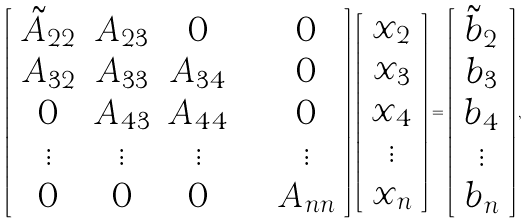<formula> <loc_0><loc_0><loc_500><loc_500>\left [ \begin{array} { c c c c c c } \tilde { A } _ { 2 2 } & A _ { 2 3 } & 0 & \cdots & 0 \\ A _ { 3 2 } & A _ { 3 3 } & A _ { 3 4 } & \cdots & 0 \\ 0 & A _ { 4 3 } & A _ { 4 4 } & \cdots & 0 \\ \vdots & \vdots & \vdots & & \vdots \\ 0 & 0 & 0 & \cdots & A _ { n n } \end{array} \right ] \, \left [ \begin{array} { c } x _ { 2 } \\ x _ { 3 } \\ x _ { 4 } \\ \vdots \\ x _ { n } \end{array} \right ] = \left [ \begin{array} { c } \tilde { b } _ { 2 } \\ b _ { 3 } \\ b _ { 4 } \\ \vdots \\ b _ { n } \end{array} \right ] ,</formula> 